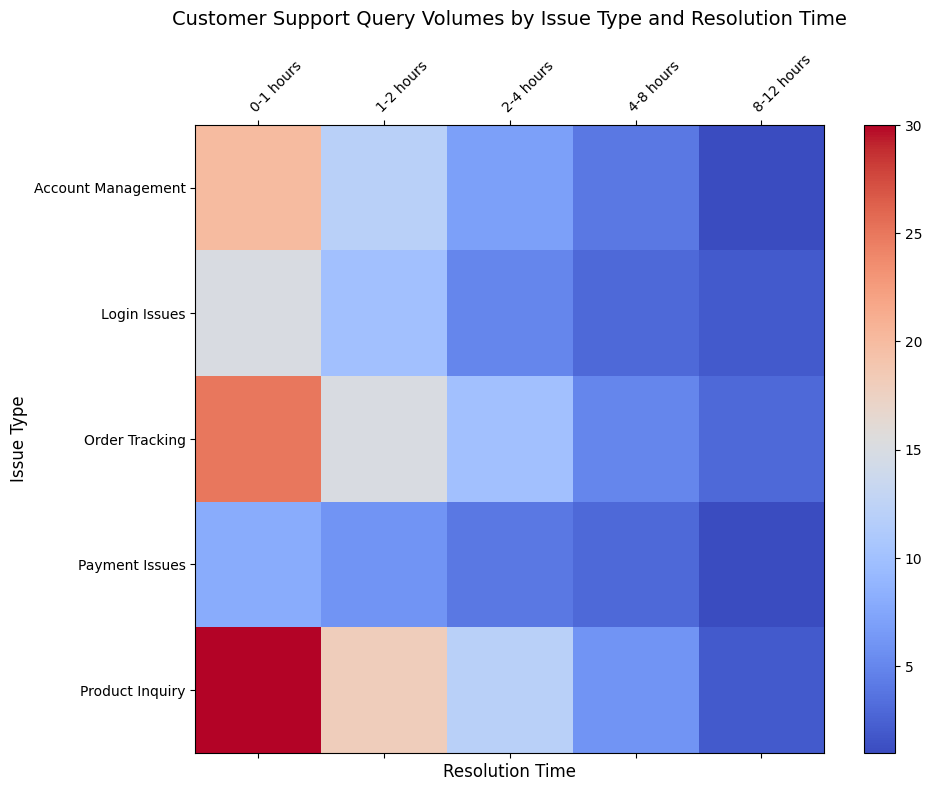Which issue type had the highest query volume resolved within 0-1 hours? Look at the heatmap and find the cell in the 0-1 hours column that has the highest value. The highest value is in the 'Product Inquiry' row. Hence, 'Product Inquiry' had the highest query volume resolved within 0-1 hours.
Answer: Product Inquiry Which resolution time for 'Order Tracking' had the lowest query volume? Locate the 'Order Tracking' row in the heatmap and identify the cell with the lowest value. The smallest number is found in the '8-12 hours' column, corresponding to the value 3.
Answer: 8-12 hours What is the total query volume for 'Account Management' issues across all resolution times? Sum the values for 'Account Management' across all resolution times: 20 + 12 + 7 + 4 + 1 = 44.
Answer: 44 Compare the query volumes for 'Login Issues' and 'Payment Issues' resolved within 4-8 hours. Which one is higher? Check the volumes in the 4-8 hours column for both 'Login Issues' and 'Payment Issues'. 'Login Issues' has 3 and 'Payment Issues' has 3. Both have the same value.
Answer: Equal What is the average query volume for 'Product Inquiry' issue type across all resolution times? Add up the values for 'Product Inquiry' and divide by the number of values: (30 + 18 + 12 + 6 + 2) / 5 = 68 / 5 = 13.6.
Answer: 13.6 Is the query volume higher for 'Order Tracking' resolved within 1-2 hours or 'Payment Issues' resolved within 0-1 hours? Compare the volume for 'Order Tracking' in the 1-2 hours column (15) with 'Payment Issues' in the 0-1 hours column (8). 'Order Tracking' has a higher query volume.
Answer: Order Tracking How does the query volume for 'Login Issues' resolved within 1-2 hours compare to 'Account Management' resolved within the same time frame? Compare the values for 'Login Issues' and 'Account Management' in the 1-2 hours column. 'Login Issues' has 10 and 'Account Management' has 12. 'Account Management' is higher.
Answer: Account Management What is the sum of query volumes for issues resolved within 2-4 hours for all issue types? Add the values for the 2-4 hours column across all issue types: 5 (Login Issues) + 7 (Account Management) + 4 (Payment Issues) + 10 (Order Tracking) + 12 (Product Inquiry) = 38.
Answer: 38 